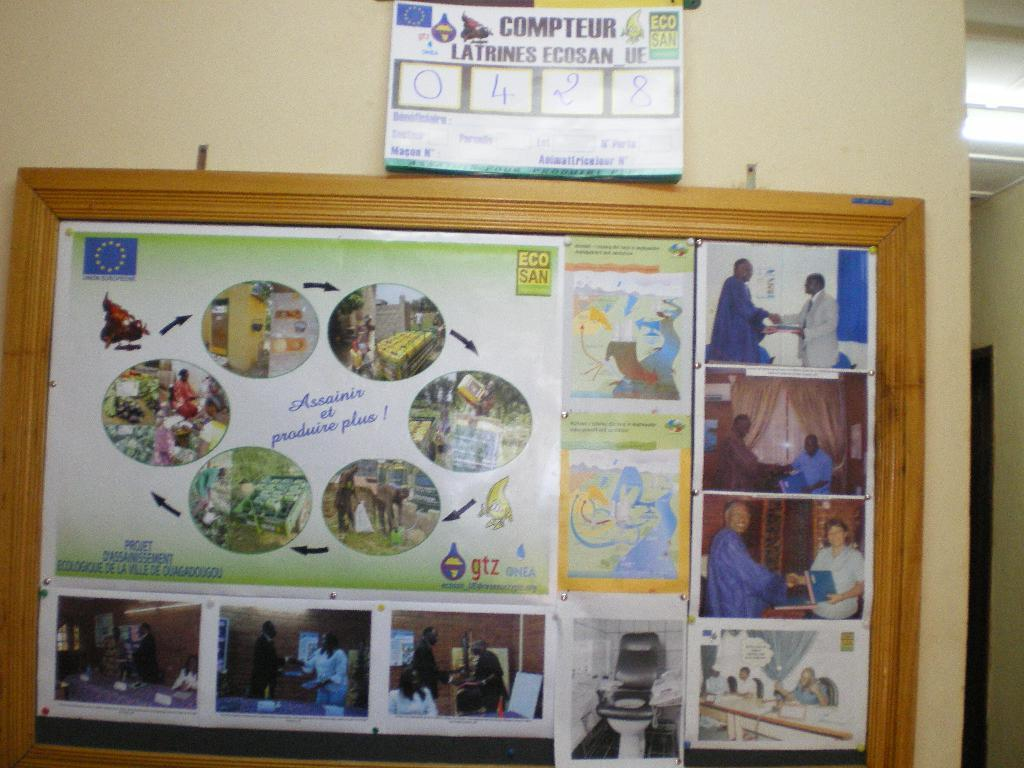Provide a one-sentence caption for the provided image. A collection of pictures and a sign above them that states COMPTEUR. 